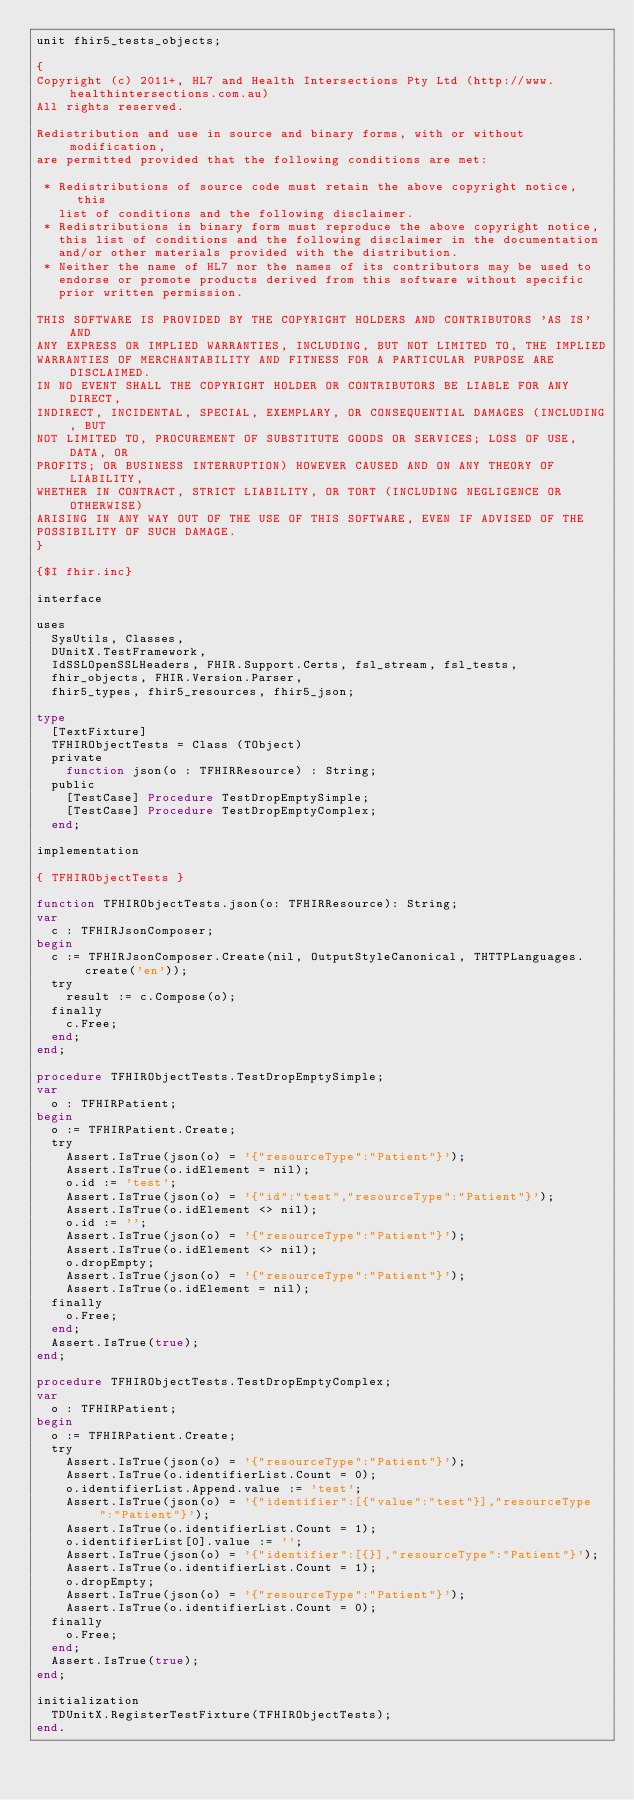<code> <loc_0><loc_0><loc_500><loc_500><_Pascal_>unit fhir5_tests_objects;

{
Copyright (c) 2011+, HL7 and Health Intersections Pty Ltd (http://www.healthintersections.com.au)
All rights reserved.

Redistribution and use in source and binary forms, with or without modification,
are permitted provided that the following conditions are met:

 * Redistributions of source code must retain the above copyright notice, this
   list of conditions and the following disclaimer.
 * Redistributions in binary form must reproduce the above copyright notice,
   this list of conditions and the following disclaimer in the documentation
   and/or other materials provided with the distribution.
 * Neither the name of HL7 nor the names of its contributors may be used to
   endorse or promote products derived from this software without specific
   prior written permission.

THIS SOFTWARE IS PROVIDED BY THE COPYRIGHT HOLDERS AND CONTRIBUTORS 'AS IS' AND
ANY EXPRESS OR IMPLIED WARRANTIES, INCLUDING, BUT NOT LIMITED TO, THE IMPLIED
WARRANTIES OF MERCHANTABILITY AND FITNESS FOR A PARTICULAR PURPOSE ARE DISCLAIMED.
IN NO EVENT SHALL THE COPYRIGHT HOLDER OR CONTRIBUTORS BE LIABLE FOR ANY DIRECT,
INDIRECT, INCIDENTAL, SPECIAL, EXEMPLARY, OR CONSEQUENTIAL DAMAGES (INCLUDING, BUT
NOT LIMITED TO, PROCUREMENT OF SUBSTITUTE GOODS OR SERVICES; LOSS OF USE, DATA, OR
PROFITS; OR BUSINESS INTERRUPTION) HOWEVER CAUSED AND ON ANY THEORY OF LIABILITY,
WHETHER IN CONTRACT, STRICT LIABILITY, OR TORT (INCLUDING NEGLIGENCE OR OTHERWISE)
ARISING IN ANY WAY OUT OF THE USE OF THIS SOFTWARE, EVEN IF ADVISED OF THE
POSSIBILITY OF SUCH DAMAGE.
}

{$I fhir.inc}

interface

uses
  SysUtils, Classes,
  DUnitX.TestFramework,
  IdSSLOpenSSLHeaders, FHIR.Support.Certs, fsl_stream, fsl_tests,
  fhir_objects, FHIR.Version.Parser,
  fhir5_types, fhir5_resources, fhir5_json;

type
  [TextFixture]
  TFHIRObjectTests = Class (TObject)
  private
    function json(o : TFHIRResource) : String;
  public
    [TestCase] Procedure TestDropEmptySimple;
    [TestCase] Procedure TestDropEmptyComplex;
  end;

implementation

{ TFHIRObjectTests }

function TFHIRObjectTests.json(o: TFHIRResource): String;
var
  c : TFHIRJsonComposer;
begin
  c := TFHIRJsonComposer.Create(nil, OutputStyleCanonical, THTTPLanguages.create('en'));
  try
    result := c.Compose(o);
  finally
    c.Free;
  end;
end;

procedure TFHIRObjectTests.TestDropEmptySimple;
var
  o : TFHIRPatient;
begin
  o := TFHIRPatient.Create;
  try
    Assert.IsTrue(json(o) = '{"resourceType":"Patient"}');
    Assert.IsTrue(o.idElement = nil);
    o.id := 'test';
    Assert.IsTrue(json(o) = '{"id":"test","resourceType":"Patient"}');
    Assert.IsTrue(o.idElement <> nil);
    o.id := '';
    Assert.IsTrue(json(o) = '{"resourceType":"Patient"}');
    Assert.IsTrue(o.idElement <> nil);
    o.dropEmpty;
    Assert.IsTrue(json(o) = '{"resourceType":"Patient"}');
    Assert.IsTrue(o.idElement = nil);
  finally
    o.Free;
  end;
  Assert.IsTrue(true);
end;

procedure TFHIRObjectTests.TestDropEmptyComplex;
var
  o : TFHIRPatient;
begin
  o := TFHIRPatient.Create;
  try
    Assert.IsTrue(json(o) = '{"resourceType":"Patient"}');
    Assert.IsTrue(o.identifierList.Count = 0);
    o.identifierList.Append.value := 'test';
    Assert.IsTrue(json(o) = '{"identifier":[{"value":"test"}],"resourceType":"Patient"}');
    Assert.IsTrue(o.identifierList.Count = 1);
    o.identifierList[0].value := '';
    Assert.IsTrue(json(o) = '{"identifier":[{}],"resourceType":"Patient"}');
    Assert.IsTrue(o.identifierList.Count = 1);
    o.dropEmpty;
    Assert.IsTrue(json(o) = '{"resourceType":"Patient"}');
    Assert.IsTrue(o.identifierList.Count = 0);
  finally
    o.Free;
  end;
  Assert.IsTrue(true);
end;

initialization
  TDUnitX.RegisterTestFixture(TFHIRObjectTests);
end.
</code> 